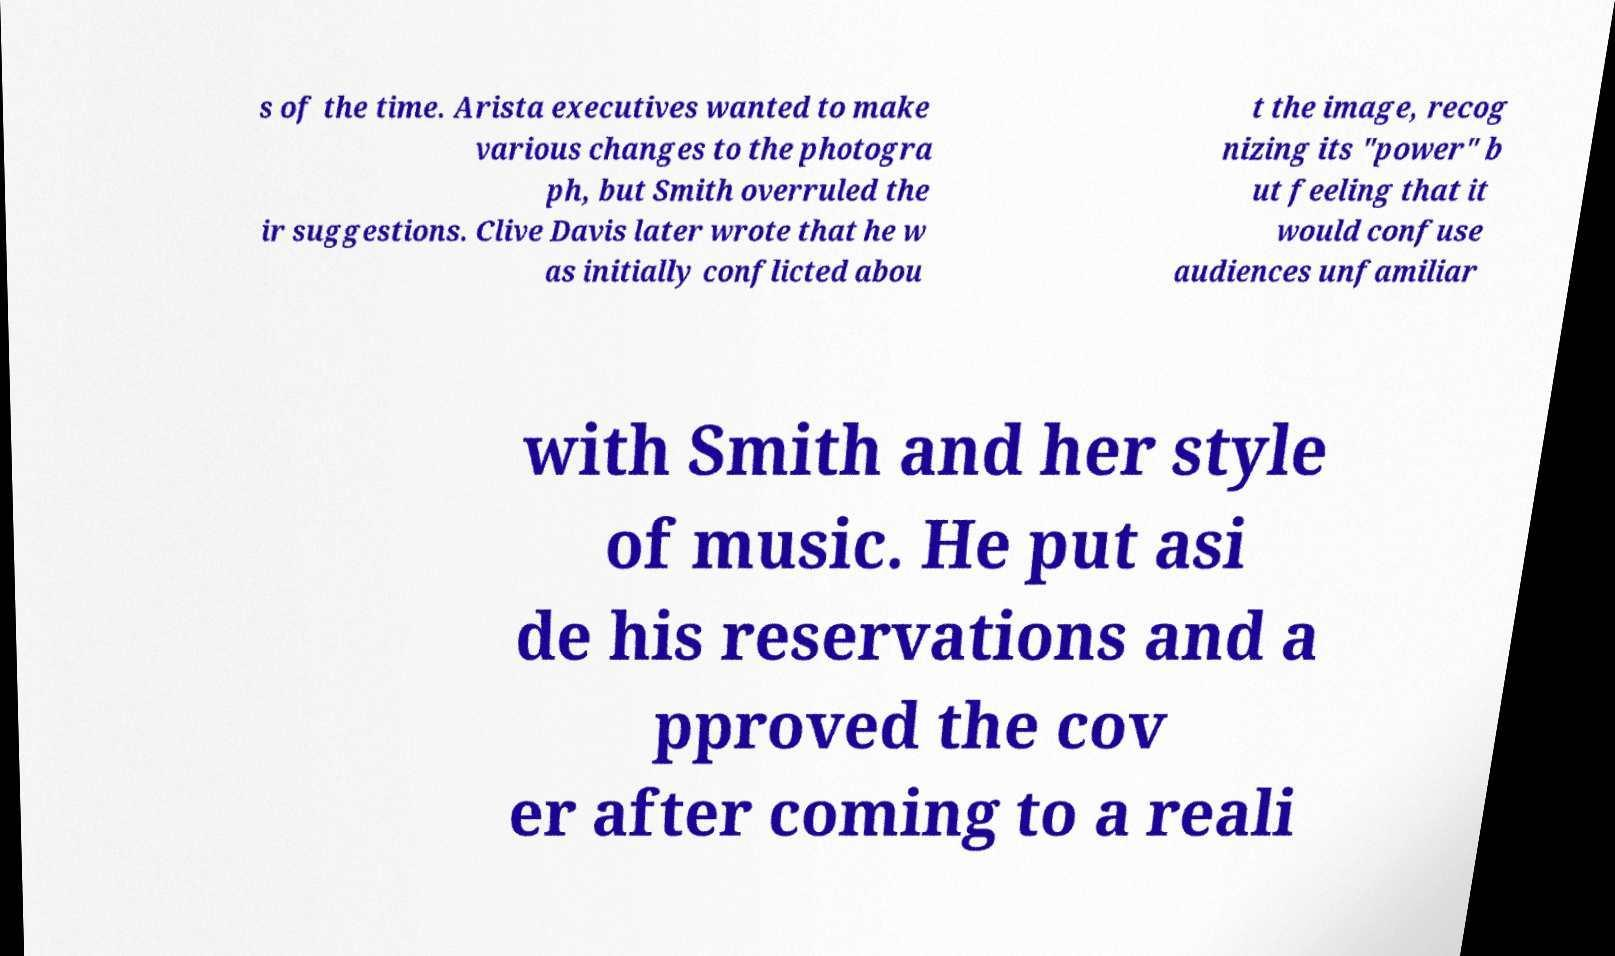Could you assist in decoding the text presented in this image and type it out clearly? s of the time. Arista executives wanted to make various changes to the photogra ph, but Smith overruled the ir suggestions. Clive Davis later wrote that he w as initially conflicted abou t the image, recog nizing its "power" b ut feeling that it would confuse audiences unfamiliar with Smith and her style of music. He put asi de his reservations and a pproved the cov er after coming to a reali 